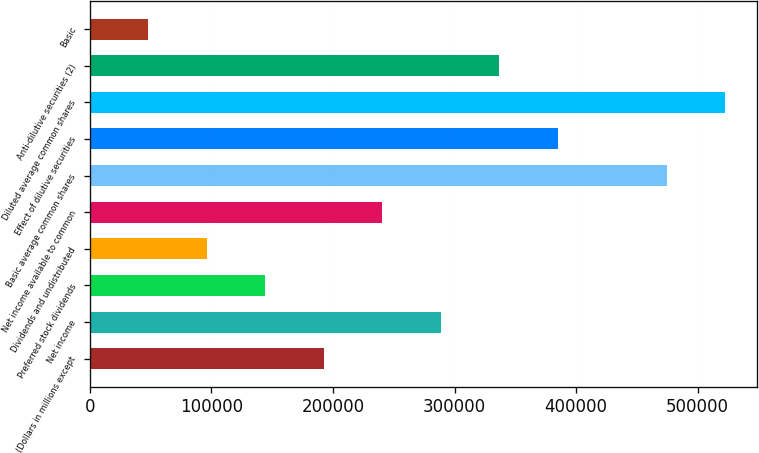Convert chart to OTSL. <chart><loc_0><loc_0><loc_500><loc_500><bar_chart><fcel>(Dollars in millions except<fcel>Net income<fcel>Preferred stock dividends<fcel>Dividends and undistributed<fcel>Net income available to common<fcel>Basic average common shares<fcel>Effect of dilutive securities<fcel>Diluted average common shares<fcel>Anti-dilutive securities (2)<fcel>Basic<nl><fcel>192454<fcel>288679<fcel>144342<fcel>96229.2<fcel>240567<fcel>474458<fcel>384904<fcel>522570<fcel>336792<fcel>48116.7<nl></chart> 